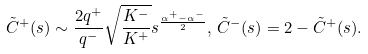Convert formula to latex. <formula><loc_0><loc_0><loc_500><loc_500>\tilde { C } ^ { + } ( s ) \sim \frac { 2 q ^ { + } } { q ^ { - } } \sqrt { \frac { K ^ { - } } { K ^ { + } } } s ^ { \frac { \alpha ^ { + } - \alpha ^ { - } } { 2 } } , \, \tilde { C } ^ { - } ( s ) = 2 - \tilde { C } ^ { + } ( s ) .</formula> 